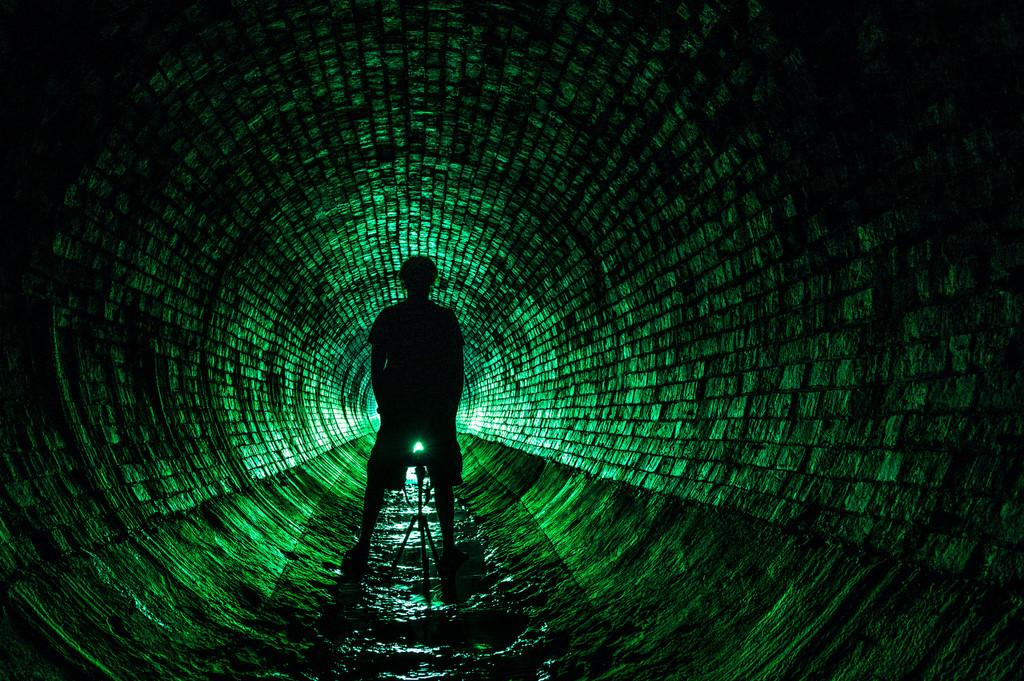What is the main structure in the center of the image? There is a brick wall in the center of the image. What can be seen illuminating the area in the image? There is a light in the image. What object is present to support or hold something in the image? There is a stand in the image. Who is present in the image? There is a person standing in the image. What natural element is visible in the image? There is water visible in the image. What color is predominant in the background of the image? The background of the image is green. What type of thunder can be heard in the image? There is no thunder present in the image; it is a silent scene. Is there a jail visible in the image? There is no jail present in the image. 